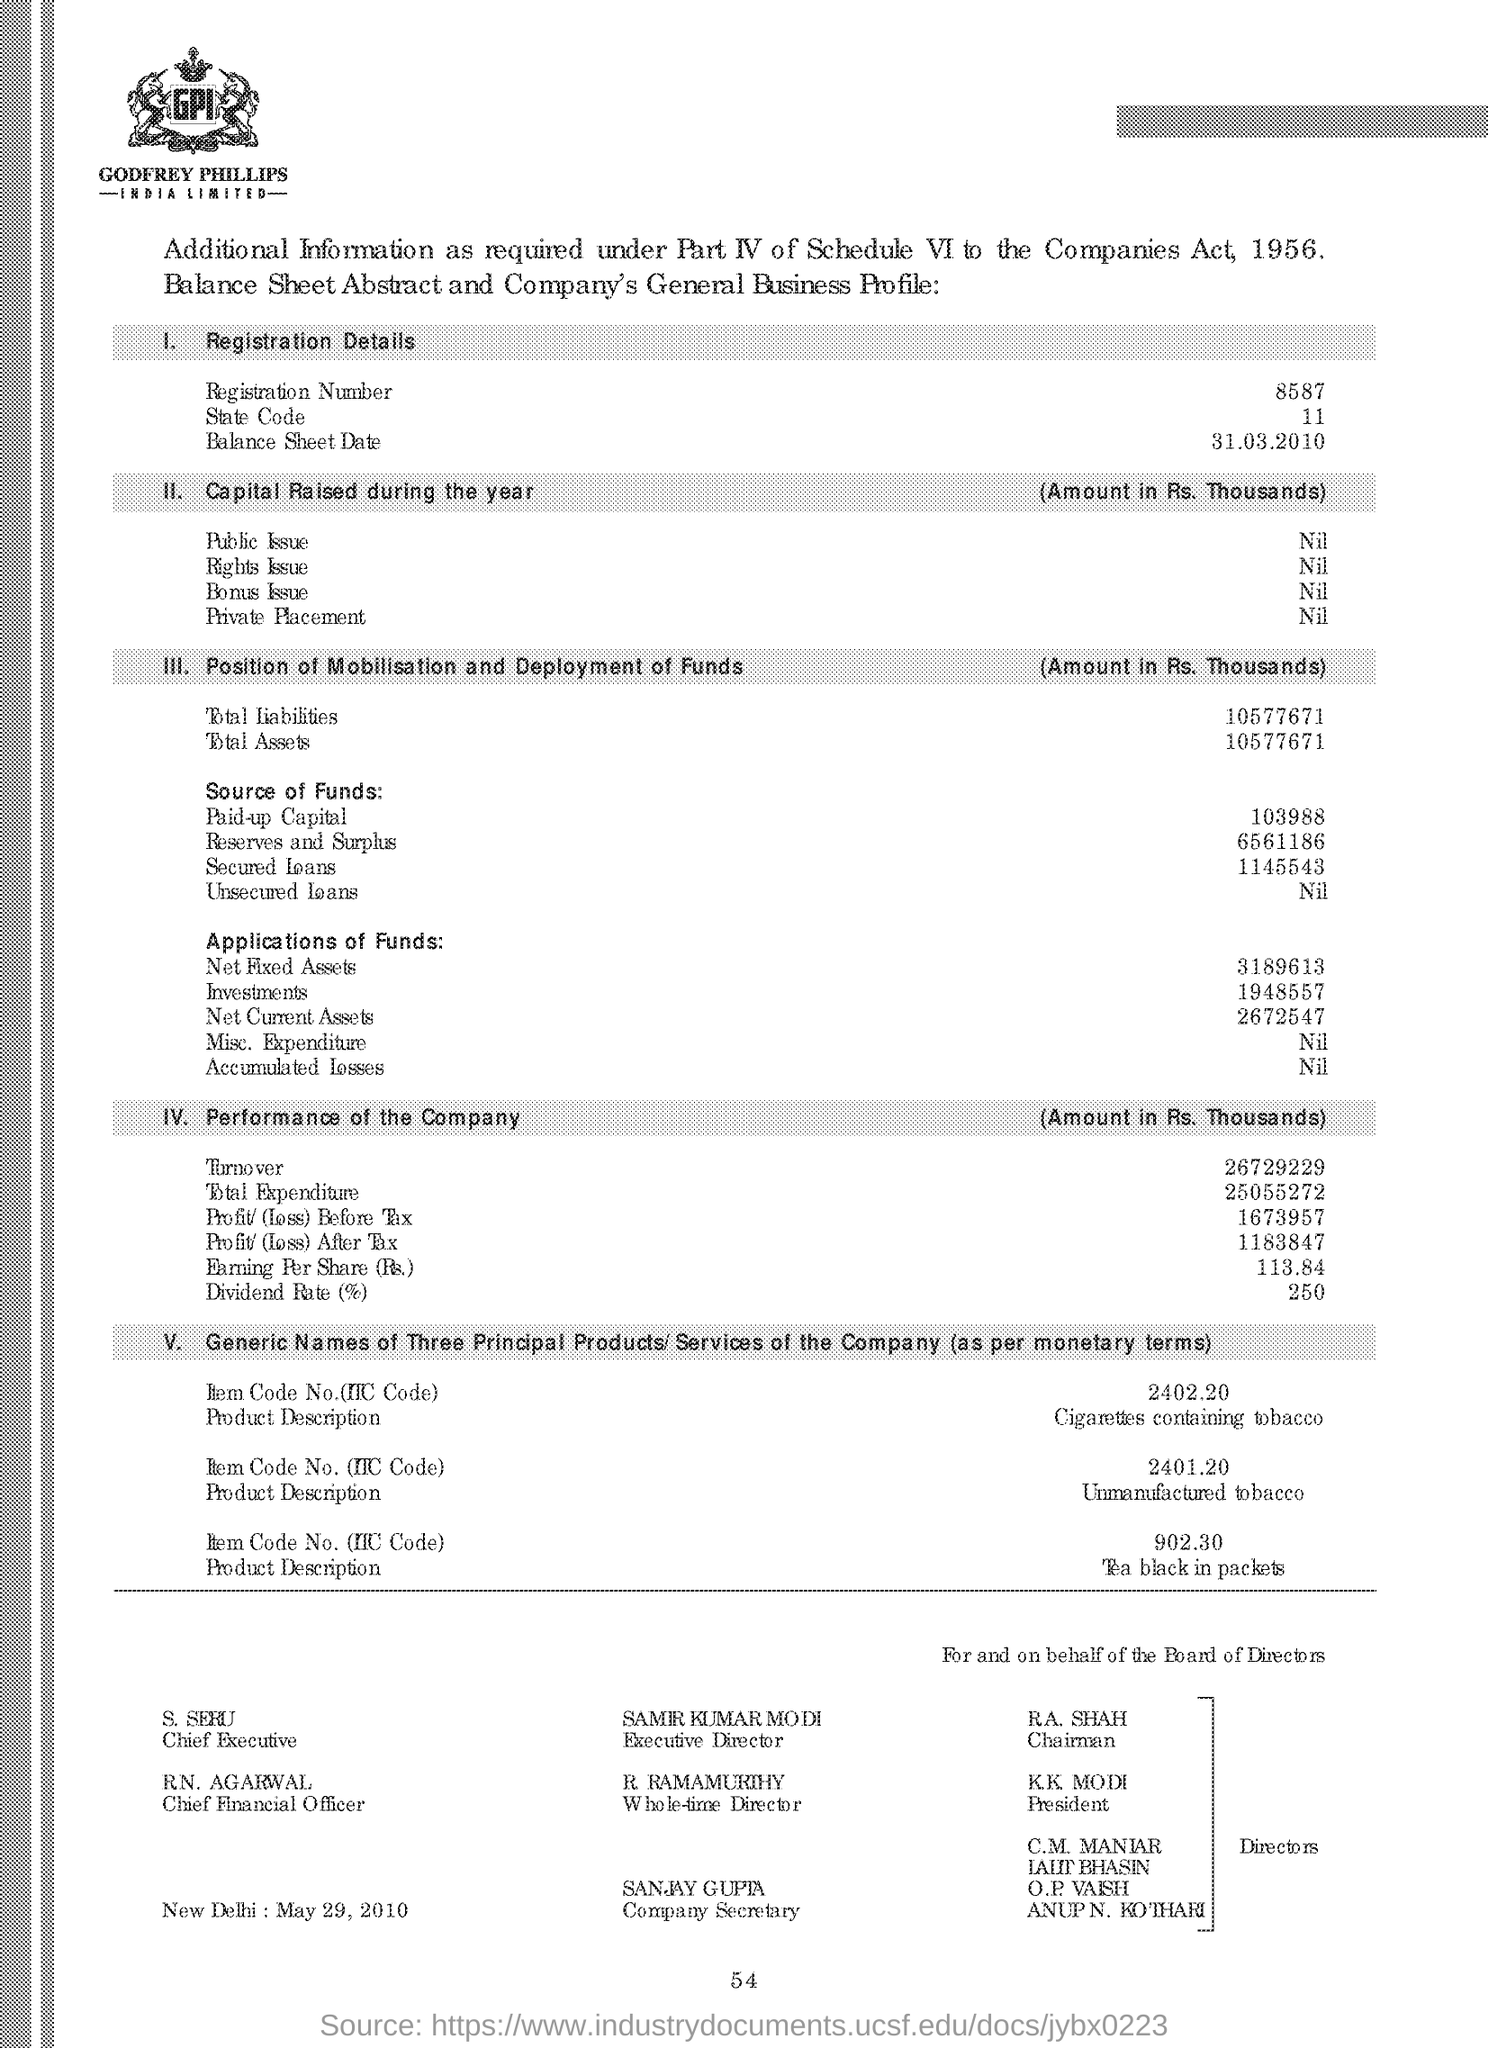Highlight a few significant elements in this photo. What is the State Code? It is 11.. What is the total amount of liabilities? It is 105,776,713. The dividend rate is 250.. The registration number is 8587. 